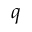Convert formula to latex. <formula><loc_0><loc_0><loc_500><loc_500>q</formula> 